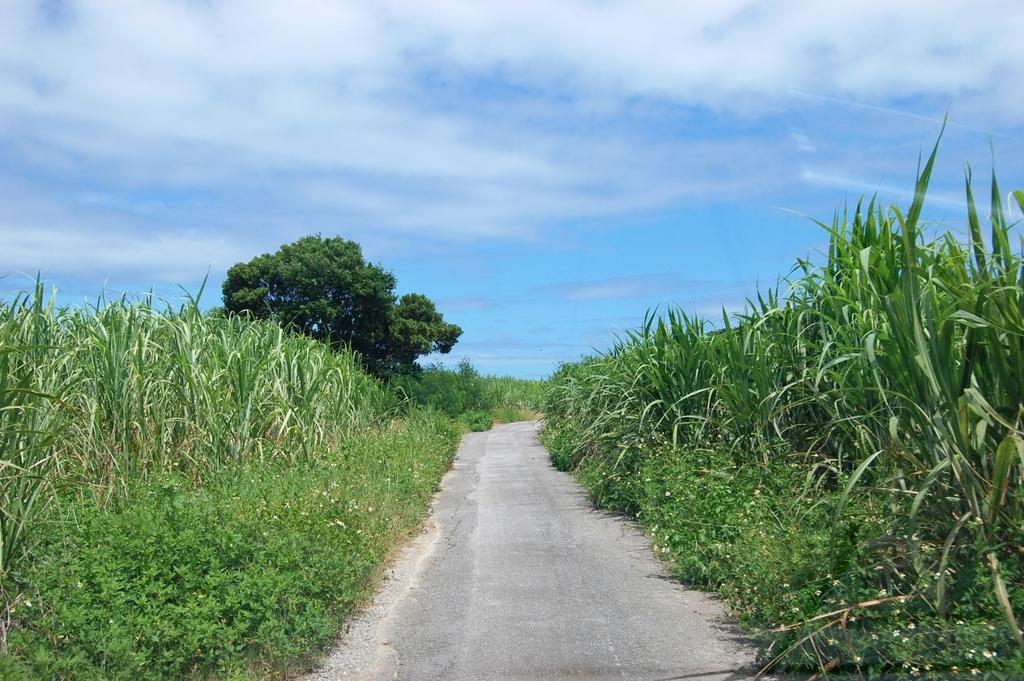What types of vegetation can be seen in the foreground of the image? There are plants and trees in the foreground of the image. What can be seen in the background of the image? The sky is visible in the image. What is the color of the sky in the image? The sky appears to be blue in the image. Can you make any assumptions about the location of the image? The image may have been taken on a farm, based on the presence of plants and trees. Can you make any assumptions about the time of day the image was taken? The image may have been taken during the day, as the sky is visible and appears to be blue. What type of honey is being used to write on the eggnog in the image? There is no honey, writing, or eggnog present in the image. 